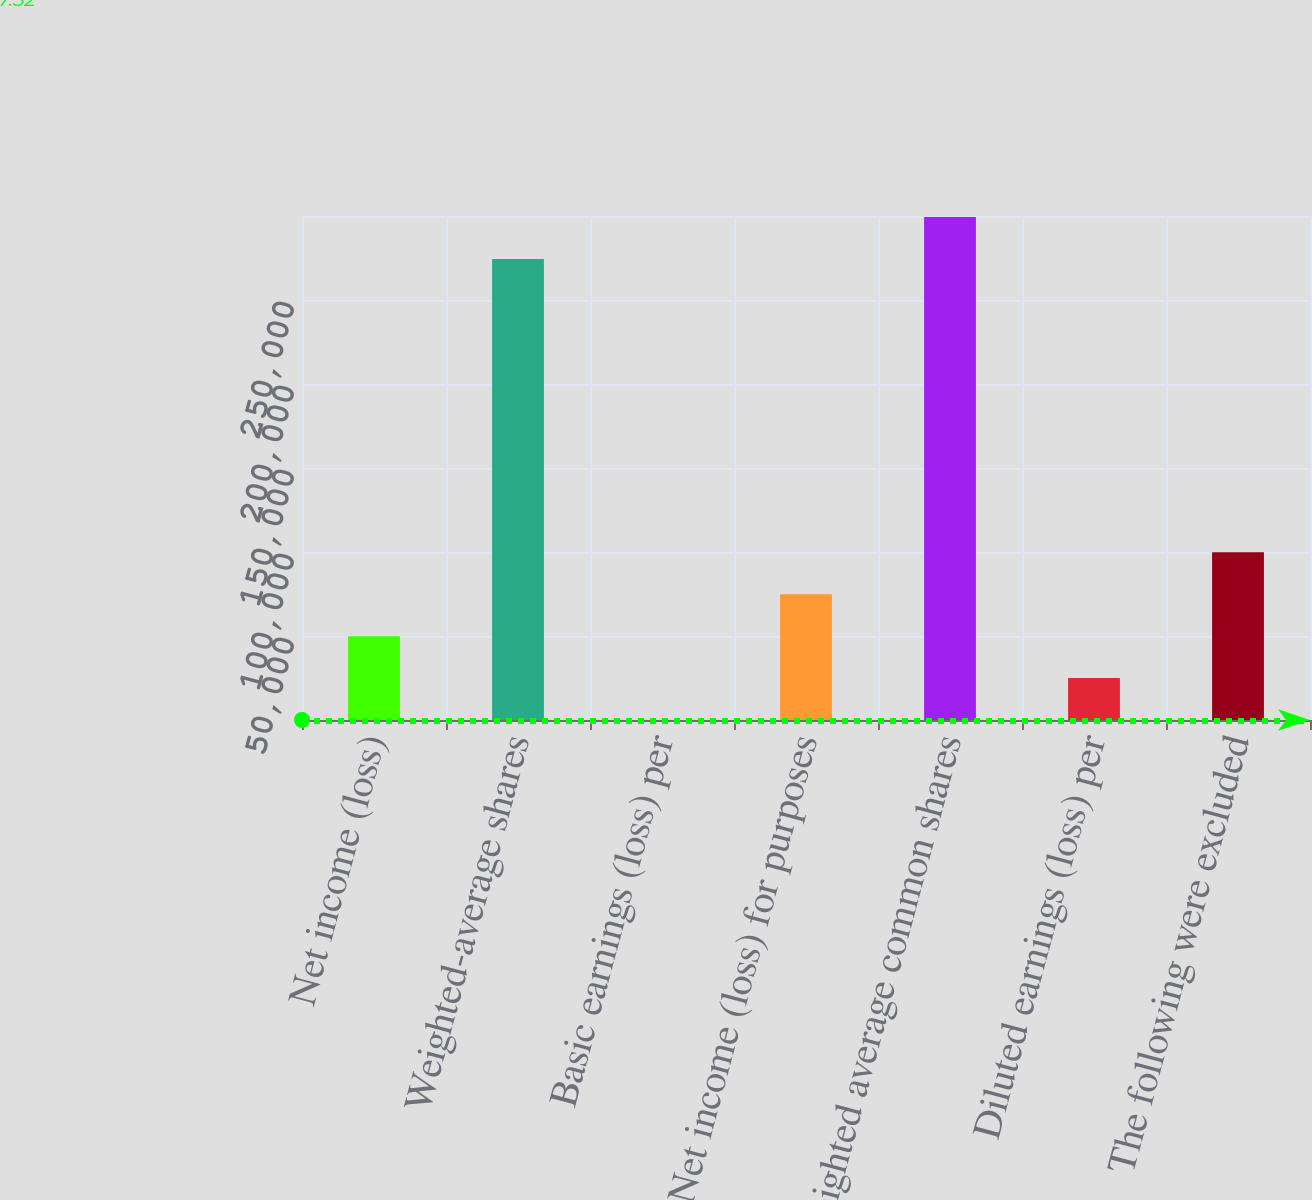Convert chart to OTSL. <chart><loc_0><loc_0><loc_500><loc_500><bar_chart><fcel>Net income (loss)<fcel>Weighted-average shares<fcel>Basic earnings (loss) per<fcel>Net income (loss) for purposes<fcel>Weighted average common shares<fcel>Diluted earnings (loss) per<fcel>The following were excluded<nl><fcel>49904<fcel>274438<fcel>7.52<fcel>74852.3<fcel>299386<fcel>24955.8<fcel>99800.5<nl></chart> 